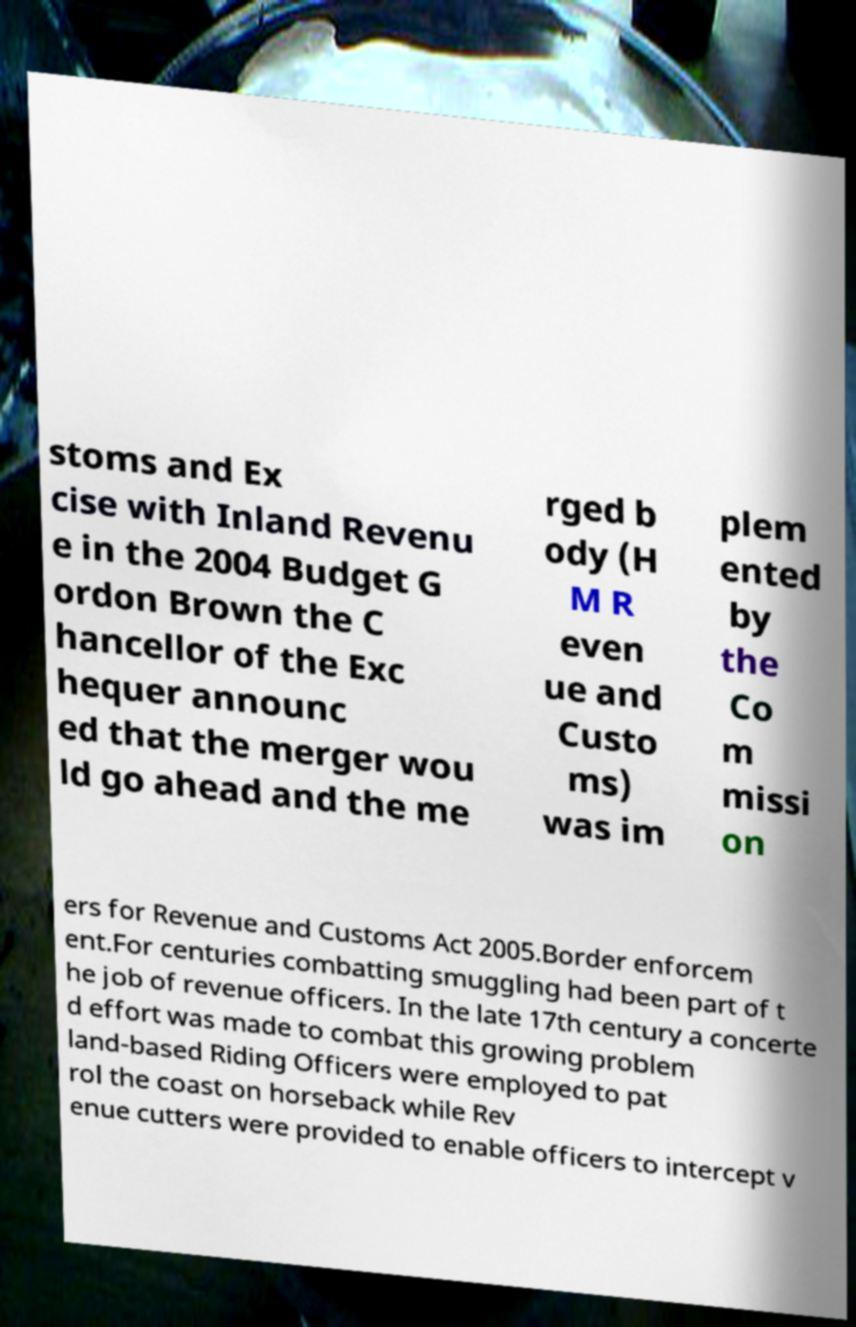Please read and relay the text visible in this image. What does it say? stoms and Ex cise with Inland Revenu e in the 2004 Budget G ordon Brown the C hancellor of the Exc hequer announc ed that the merger wou ld go ahead and the me rged b ody (H M R even ue and Custo ms) was im plem ented by the Co m missi on ers for Revenue and Customs Act 2005.Border enforcem ent.For centuries combatting smuggling had been part of t he job of revenue officers. In the late 17th century a concerte d effort was made to combat this growing problem land-based Riding Officers were employed to pat rol the coast on horseback while Rev enue cutters were provided to enable officers to intercept v 